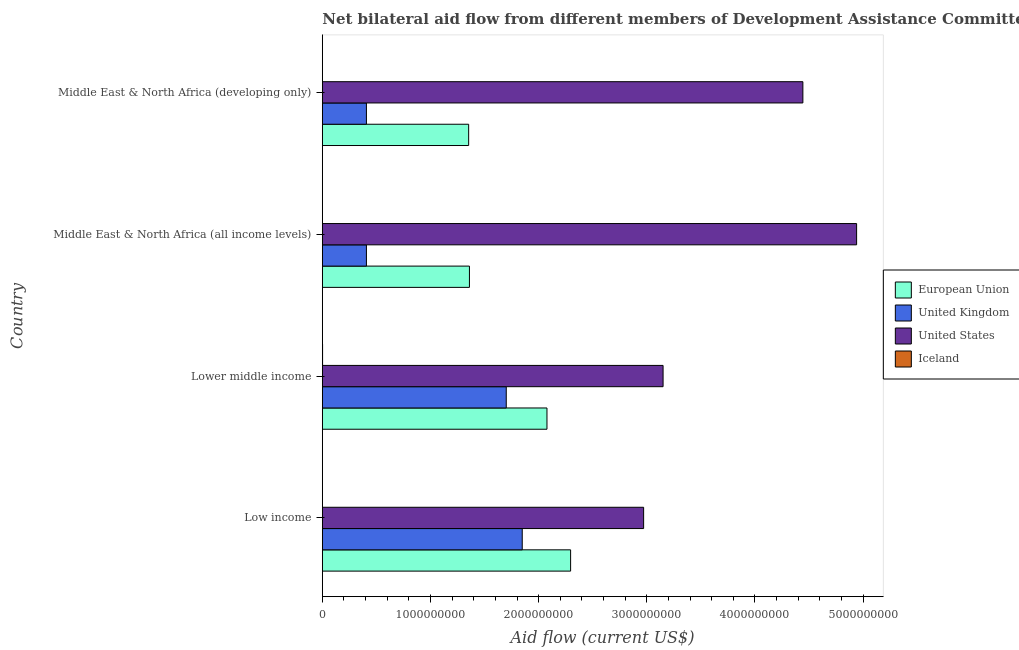How many groups of bars are there?
Provide a succinct answer. 4. Are the number of bars on each tick of the Y-axis equal?
Make the answer very short. Yes. How many bars are there on the 4th tick from the bottom?
Offer a terse response. 4. What is the label of the 1st group of bars from the top?
Provide a succinct answer. Middle East & North Africa (developing only). In how many cases, is the number of bars for a given country not equal to the number of legend labels?
Offer a very short reply. 0. What is the amount of aid given by us in Middle East & North Africa (all income levels)?
Your response must be concise. 4.94e+09. Across all countries, what is the maximum amount of aid given by iceland?
Offer a very short reply. 2.28e+06. Across all countries, what is the minimum amount of aid given by uk?
Make the answer very short. 4.08e+08. In which country was the amount of aid given by eu maximum?
Your answer should be very brief. Low income. In which country was the amount of aid given by uk minimum?
Provide a short and direct response. Middle East & North Africa (all income levels). What is the total amount of aid given by uk in the graph?
Provide a short and direct response. 4.36e+09. What is the difference between the amount of aid given by uk in Low income and that in Lower middle income?
Provide a succinct answer. 1.48e+08. What is the difference between the amount of aid given by eu in Middle East & North Africa (developing only) and the amount of aid given by us in Low income?
Your answer should be very brief. -1.62e+09. What is the average amount of aid given by uk per country?
Give a very brief answer. 1.09e+09. What is the difference between the amount of aid given by us and amount of aid given by uk in Middle East & North Africa (all income levels)?
Provide a succinct answer. 4.53e+09. What is the ratio of the amount of aid given by us in Middle East & North Africa (all income levels) to that in Middle East & North Africa (developing only)?
Keep it short and to the point. 1.11. Is the amount of aid given by us in Low income less than that in Middle East & North Africa (developing only)?
Ensure brevity in your answer.  Yes. What is the difference between the highest and the second highest amount of aid given by eu?
Offer a terse response. 2.19e+08. What is the difference between the highest and the lowest amount of aid given by eu?
Make the answer very short. 9.42e+08. In how many countries, is the amount of aid given by uk greater than the average amount of aid given by uk taken over all countries?
Offer a terse response. 2. What does the 1st bar from the top in Low income represents?
Your answer should be compact. Iceland. How many bars are there?
Make the answer very short. 16. How many countries are there in the graph?
Your response must be concise. 4. What is the difference between two consecutive major ticks on the X-axis?
Provide a short and direct response. 1.00e+09. Does the graph contain grids?
Provide a succinct answer. No. Where does the legend appear in the graph?
Your answer should be very brief. Center right. How many legend labels are there?
Your answer should be compact. 4. How are the legend labels stacked?
Make the answer very short. Vertical. What is the title of the graph?
Your answer should be very brief. Net bilateral aid flow from different members of Development Assistance Committee in the year 2004. Does "Debt policy" appear as one of the legend labels in the graph?
Ensure brevity in your answer.  No. What is the label or title of the X-axis?
Make the answer very short. Aid flow (current US$). What is the Aid flow (current US$) of European Union in Low income?
Your answer should be compact. 2.30e+09. What is the Aid flow (current US$) of United Kingdom in Low income?
Give a very brief answer. 1.85e+09. What is the Aid flow (current US$) in United States in Low income?
Your response must be concise. 2.97e+09. What is the Aid flow (current US$) of Iceland in Low income?
Your answer should be very brief. 1.54e+06. What is the Aid flow (current US$) in European Union in Lower middle income?
Your answer should be compact. 2.08e+09. What is the Aid flow (current US$) in United Kingdom in Lower middle income?
Provide a succinct answer. 1.70e+09. What is the Aid flow (current US$) of United States in Lower middle income?
Your answer should be very brief. 3.15e+09. What is the Aid flow (current US$) in Iceland in Lower middle income?
Make the answer very short. 2.28e+06. What is the Aid flow (current US$) in European Union in Middle East & North Africa (all income levels)?
Keep it short and to the point. 1.36e+09. What is the Aid flow (current US$) of United Kingdom in Middle East & North Africa (all income levels)?
Offer a terse response. 4.08e+08. What is the Aid flow (current US$) in United States in Middle East & North Africa (all income levels)?
Your response must be concise. 4.94e+09. What is the Aid flow (current US$) of Iceland in Middle East & North Africa (all income levels)?
Your answer should be compact. 1.24e+06. What is the Aid flow (current US$) in European Union in Middle East & North Africa (developing only)?
Make the answer very short. 1.35e+09. What is the Aid flow (current US$) in United Kingdom in Middle East & North Africa (developing only)?
Your answer should be very brief. 4.08e+08. What is the Aid flow (current US$) of United States in Middle East & North Africa (developing only)?
Keep it short and to the point. 4.44e+09. What is the Aid flow (current US$) in Iceland in Middle East & North Africa (developing only)?
Ensure brevity in your answer.  1.27e+06. Across all countries, what is the maximum Aid flow (current US$) of European Union?
Your answer should be compact. 2.30e+09. Across all countries, what is the maximum Aid flow (current US$) in United Kingdom?
Offer a terse response. 1.85e+09. Across all countries, what is the maximum Aid flow (current US$) of United States?
Your response must be concise. 4.94e+09. Across all countries, what is the maximum Aid flow (current US$) of Iceland?
Give a very brief answer. 2.28e+06. Across all countries, what is the minimum Aid flow (current US$) in European Union?
Your answer should be compact. 1.35e+09. Across all countries, what is the minimum Aid flow (current US$) in United Kingdom?
Keep it short and to the point. 4.08e+08. Across all countries, what is the minimum Aid flow (current US$) in United States?
Keep it short and to the point. 2.97e+09. Across all countries, what is the minimum Aid flow (current US$) of Iceland?
Your answer should be very brief. 1.24e+06. What is the total Aid flow (current US$) of European Union in the graph?
Offer a very short reply. 7.09e+09. What is the total Aid flow (current US$) of United Kingdom in the graph?
Your response must be concise. 4.36e+09. What is the total Aid flow (current US$) of United States in the graph?
Your answer should be compact. 1.55e+1. What is the total Aid flow (current US$) in Iceland in the graph?
Provide a short and direct response. 6.33e+06. What is the difference between the Aid flow (current US$) of European Union in Low income and that in Lower middle income?
Provide a short and direct response. 2.19e+08. What is the difference between the Aid flow (current US$) of United Kingdom in Low income and that in Lower middle income?
Offer a terse response. 1.48e+08. What is the difference between the Aid flow (current US$) in United States in Low income and that in Lower middle income?
Keep it short and to the point. -1.80e+08. What is the difference between the Aid flow (current US$) in Iceland in Low income and that in Lower middle income?
Your response must be concise. -7.40e+05. What is the difference between the Aid flow (current US$) of European Union in Low income and that in Middle East & North Africa (all income levels)?
Make the answer very short. 9.35e+08. What is the difference between the Aid flow (current US$) of United Kingdom in Low income and that in Middle East & North Africa (all income levels)?
Ensure brevity in your answer.  1.44e+09. What is the difference between the Aid flow (current US$) of United States in Low income and that in Middle East & North Africa (all income levels)?
Make the answer very short. -1.97e+09. What is the difference between the Aid flow (current US$) in Iceland in Low income and that in Middle East & North Africa (all income levels)?
Your answer should be very brief. 3.00e+05. What is the difference between the Aid flow (current US$) of European Union in Low income and that in Middle East & North Africa (developing only)?
Keep it short and to the point. 9.42e+08. What is the difference between the Aid flow (current US$) in United Kingdom in Low income and that in Middle East & North Africa (developing only)?
Offer a terse response. 1.44e+09. What is the difference between the Aid flow (current US$) of United States in Low income and that in Middle East & North Africa (developing only)?
Your answer should be compact. -1.47e+09. What is the difference between the Aid flow (current US$) in European Union in Lower middle income and that in Middle East & North Africa (all income levels)?
Provide a short and direct response. 7.17e+08. What is the difference between the Aid flow (current US$) of United Kingdom in Lower middle income and that in Middle East & North Africa (all income levels)?
Keep it short and to the point. 1.29e+09. What is the difference between the Aid flow (current US$) of United States in Lower middle income and that in Middle East & North Africa (all income levels)?
Offer a terse response. -1.79e+09. What is the difference between the Aid flow (current US$) of Iceland in Lower middle income and that in Middle East & North Africa (all income levels)?
Your response must be concise. 1.04e+06. What is the difference between the Aid flow (current US$) of European Union in Lower middle income and that in Middle East & North Africa (developing only)?
Your response must be concise. 7.24e+08. What is the difference between the Aid flow (current US$) of United Kingdom in Lower middle income and that in Middle East & North Africa (developing only)?
Keep it short and to the point. 1.29e+09. What is the difference between the Aid flow (current US$) of United States in Lower middle income and that in Middle East & North Africa (developing only)?
Make the answer very short. -1.29e+09. What is the difference between the Aid flow (current US$) in Iceland in Lower middle income and that in Middle East & North Africa (developing only)?
Ensure brevity in your answer.  1.01e+06. What is the difference between the Aid flow (current US$) in European Union in Middle East & North Africa (all income levels) and that in Middle East & North Africa (developing only)?
Make the answer very short. 7.17e+06. What is the difference between the Aid flow (current US$) in United Kingdom in Middle East & North Africa (all income levels) and that in Middle East & North Africa (developing only)?
Offer a very short reply. 0. What is the difference between the Aid flow (current US$) of United States in Middle East & North Africa (all income levels) and that in Middle East & North Africa (developing only)?
Ensure brevity in your answer.  4.97e+08. What is the difference between the Aid flow (current US$) in European Union in Low income and the Aid flow (current US$) in United Kingdom in Lower middle income?
Provide a succinct answer. 5.95e+08. What is the difference between the Aid flow (current US$) in European Union in Low income and the Aid flow (current US$) in United States in Lower middle income?
Offer a very short reply. -8.55e+08. What is the difference between the Aid flow (current US$) of European Union in Low income and the Aid flow (current US$) of Iceland in Lower middle income?
Provide a short and direct response. 2.29e+09. What is the difference between the Aid flow (current US$) of United Kingdom in Low income and the Aid flow (current US$) of United States in Lower middle income?
Make the answer very short. -1.30e+09. What is the difference between the Aid flow (current US$) in United Kingdom in Low income and the Aid flow (current US$) in Iceland in Lower middle income?
Make the answer very short. 1.85e+09. What is the difference between the Aid flow (current US$) in United States in Low income and the Aid flow (current US$) in Iceland in Lower middle income?
Your response must be concise. 2.97e+09. What is the difference between the Aid flow (current US$) in European Union in Low income and the Aid flow (current US$) in United Kingdom in Middle East & North Africa (all income levels)?
Ensure brevity in your answer.  1.89e+09. What is the difference between the Aid flow (current US$) in European Union in Low income and the Aid flow (current US$) in United States in Middle East & North Africa (all income levels)?
Your response must be concise. -2.64e+09. What is the difference between the Aid flow (current US$) in European Union in Low income and the Aid flow (current US$) in Iceland in Middle East & North Africa (all income levels)?
Offer a terse response. 2.29e+09. What is the difference between the Aid flow (current US$) of United Kingdom in Low income and the Aid flow (current US$) of United States in Middle East & North Africa (all income levels)?
Offer a very short reply. -3.09e+09. What is the difference between the Aid flow (current US$) in United Kingdom in Low income and the Aid flow (current US$) in Iceland in Middle East & North Africa (all income levels)?
Offer a terse response. 1.85e+09. What is the difference between the Aid flow (current US$) of United States in Low income and the Aid flow (current US$) of Iceland in Middle East & North Africa (all income levels)?
Offer a terse response. 2.97e+09. What is the difference between the Aid flow (current US$) of European Union in Low income and the Aid flow (current US$) of United Kingdom in Middle East & North Africa (developing only)?
Ensure brevity in your answer.  1.89e+09. What is the difference between the Aid flow (current US$) in European Union in Low income and the Aid flow (current US$) in United States in Middle East & North Africa (developing only)?
Ensure brevity in your answer.  -2.15e+09. What is the difference between the Aid flow (current US$) in European Union in Low income and the Aid flow (current US$) in Iceland in Middle East & North Africa (developing only)?
Your answer should be very brief. 2.29e+09. What is the difference between the Aid flow (current US$) in United Kingdom in Low income and the Aid flow (current US$) in United States in Middle East & North Africa (developing only)?
Make the answer very short. -2.59e+09. What is the difference between the Aid flow (current US$) of United Kingdom in Low income and the Aid flow (current US$) of Iceland in Middle East & North Africa (developing only)?
Ensure brevity in your answer.  1.85e+09. What is the difference between the Aid flow (current US$) in United States in Low income and the Aid flow (current US$) in Iceland in Middle East & North Africa (developing only)?
Give a very brief answer. 2.97e+09. What is the difference between the Aid flow (current US$) of European Union in Lower middle income and the Aid flow (current US$) of United Kingdom in Middle East & North Africa (all income levels)?
Make the answer very short. 1.67e+09. What is the difference between the Aid flow (current US$) in European Union in Lower middle income and the Aid flow (current US$) in United States in Middle East & North Africa (all income levels)?
Provide a succinct answer. -2.86e+09. What is the difference between the Aid flow (current US$) of European Union in Lower middle income and the Aid flow (current US$) of Iceland in Middle East & North Africa (all income levels)?
Ensure brevity in your answer.  2.08e+09. What is the difference between the Aid flow (current US$) in United Kingdom in Lower middle income and the Aid flow (current US$) in United States in Middle East & North Africa (all income levels)?
Your response must be concise. -3.24e+09. What is the difference between the Aid flow (current US$) of United Kingdom in Lower middle income and the Aid flow (current US$) of Iceland in Middle East & North Africa (all income levels)?
Your answer should be compact. 1.70e+09. What is the difference between the Aid flow (current US$) in United States in Lower middle income and the Aid flow (current US$) in Iceland in Middle East & North Africa (all income levels)?
Provide a succinct answer. 3.15e+09. What is the difference between the Aid flow (current US$) of European Union in Lower middle income and the Aid flow (current US$) of United Kingdom in Middle East & North Africa (developing only)?
Your response must be concise. 1.67e+09. What is the difference between the Aid flow (current US$) in European Union in Lower middle income and the Aid flow (current US$) in United States in Middle East & North Africa (developing only)?
Your response must be concise. -2.37e+09. What is the difference between the Aid flow (current US$) in European Union in Lower middle income and the Aid flow (current US$) in Iceland in Middle East & North Africa (developing only)?
Your answer should be compact. 2.08e+09. What is the difference between the Aid flow (current US$) of United Kingdom in Lower middle income and the Aid flow (current US$) of United States in Middle East & North Africa (developing only)?
Keep it short and to the point. -2.74e+09. What is the difference between the Aid flow (current US$) of United Kingdom in Lower middle income and the Aid flow (current US$) of Iceland in Middle East & North Africa (developing only)?
Your response must be concise. 1.70e+09. What is the difference between the Aid flow (current US$) in United States in Lower middle income and the Aid flow (current US$) in Iceland in Middle East & North Africa (developing only)?
Offer a very short reply. 3.15e+09. What is the difference between the Aid flow (current US$) in European Union in Middle East & North Africa (all income levels) and the Aid flow (current US$) in United Kingdom in Middle East & North Africa (developing only)?
Offer a very short reply. 9.52e+08. What is the difference between the Aid flow (current US$) in European Union in Middle East & North Africa (all income levels) and the Aid flow (current US$) in United States in Middle East & North Africa (developing only)?
Make the answer very short. -3.08e+09. What is the difference between the Aid flow (current US$) of European Union in Middle East & North Africa (all income levels) and the Aid flow (current US$) of Iceland in Middle East & North Africa (developing only)?
Offer a terse response. 1.36e+09. What is the difference between the Aid flow (current US$) of United Kingdom in Middle East & North Africa (all income levels) and the Aid flow (current US$) of United States in Middle East & North Africa (developing only)?
Ensure brevity in your answer.  -4.04e+09. What is the difference between the Aid flow (current US$) in United Kingdom in Middle East & North Africa (all income levels) and the Aid flow (current US$) in Iceland in Middle East & North Africa (developing only)?
Ensure brevity in your answer.  4.06e+08. What is the difference between the Aid flow (current US$) of United States in Middle East & North Africa (all income levels) and the Aid flow (current US$) of Iceland in Middle East & North Africa (developing only)?
Offer a very short reply. 4.94e+09. What is the average Aid flow (current US$) of European Union per country?
Offer a very short reply. 1.77e+09. What is the average Aid flow (current US$) in United Kingdom per country?
Make the answer very short. 1.09e+09. What is the average Aid flow (current US$) of United States per country?
Provide a short and direct response. 3.88e+09. What is the average Aid flow (current US$) of Iceland per country?
Provide a succinct answer. 1.58e+06. What is the difference between the Aid flow (current US$) in European Union and Aid flow (current US$) in United Kingdom in Low income?
Provide a succinct answer. 4.47e+08. What is the difference between the Aid flow (current US$) of European Union and Aid flow (current US$) of United States in Low income?
Give a very brief answer. -6.75e+08. What is the difference between the Aid flow (current US$) in European Union and Aid flow (current US$) in Iceland in Low income?
Give a very brief answer. 2.29e+09. What is the difference between the Aid flow (current US$) of United Kingdom and Aid flow (current US$) of United States in Low income?
Offer a very short reply. -1.12e+09. What is the difference between the Aid flow (current US$) of United Kingdom and Aid flow (current US$) of Iceland in Low income?
Give a very brief answer. 1.85e+09. What is the difference between the Aid flow (current US$) in United States and Aid flow (current US$) in Iceland in Low income?
Your answer should be compact. 2.97e+09. What is the difference between the Aid flow (current US$) of European Union and Aid flow (current US$) of United Kingdom in Lower middle income?
Your answer should be very brief. 3.76e+08. What is the difference between the Aid flow (current US$) in European Union and Aid flow (current US$) in United States in Lower middle income?
Keep it short and to the point. -1.07e+09. What is the difference between the Aid flow (current US$) of European Union and Aid flow (current US$) of Iceland in Lower middle income?
Your answer should be compact. 2.07e+09. What is the difference between the Aid flow (current US$) in United Kingdom and Aid flow (current US$) in United States in Lower middle income?
Ensure brevity in your answer.  -1.45e+09. What is the difference between the Aid flow (current US$) of United Kingdom and Aid flow (current US$) of Iceland in Lower middle income?
Your answer should be compact. 1.70e+09. What is the difference between the Aid flow (current US$) of United States and Aid flow (current US$) of Iceland in Lower middle income?
Provide a succinct answer. 3.15e+09. What is the difference between the Aid flow (current US$) in European Union and Aid flow (current US$) in United Kingdom in Middle East & North Africa (all income levels)?
Your answer should be compact. 9.52e+08. What is the difference between the Aid flow (current US$) of European Union and Aid flow (current US$) of United States in Middle East & North Africa (all income levels)?
Offer a terse response. -3.58e+09. What is the difference between the Aid flow (current US$) of European Union and Aid flow (current US$) of Iceland in Middle East & North Africa (all income levels)?
Give a very brief answer. 1.36e+09. What is the difference between the Aid flow (current US$) in United Kingdom and Aid flow (current US$) in United States in Middle East & North Africa (all income levels)?
Provide a succinct answer. -4.53e+09. What is the difference between the Aid flow (current US$) of United Kingdom and Aid flow (current US$) of Iceland in Middle East & North Africa (all income levels)?
Offer a very short reply. 4.06e+08. What is the difference between the Aid flow (current US$) in United States and Aid flow (current US$) in Iceland in Middle East & North Africa (all income levels)?
Provide a short and direct response. 4.94e+09. What is the difference between the Aid flow (current US$) of European Union and Aid flow (current US$) of United Kingdom in Middle East & North Africa (developing only)?
Offer a terse response. 9.45e+08. What is the difference between the Aid flow (current US$) in European Union and Aid flow (current US$) in United States in Middle East & North Africa (developing only)?
Offer a very short reply. -3.09e+09. What is the difference between the Aid flow (current US$) in European Union and Aid flow (current US$) in Iceland in Middle East & North Africa (developing only)?
Give a very brief answer. 1.35e+09. What is the difference between the Aid flow (current US$) in United Kingdom and Aid flow (current US$) in United States in Middle East & North Africa (developing only)?
Give a very brief answer. -4.04e+09. What is the difference between the Aid flow (current US$) of United Kingdom and Aid flow (current US$) of Iceland in Middle East & North Africa (developing only)?
Keep it short and to the point. 4.06e+08. What is the difference between the Aid flow (current US$) in United States and Aid flow (current US$) in Iceland in Middle East & North Africa (developing only)?
Provide a short and direct response. 4.44e+09. What is the ratio of the Aid flow (current US$) of European Union in Low income to that in Lower middle income?
Offer a very short reply. 1.11. What is the ratio of the Aid flow (current US$) of United Kingdom in Low income to that in Lower middle income?
Give a very brief answer. 1.09. What is the ratio of the Aid flow (current US$) in United States in Low income to that in Lower middle income?
Keep it short and to the point. 0.94. What is the ratio of the Aid flow (current US$) in Iceland in Low income to that in Lower middle income?
Your answer should be very brief. 0.68. What is the ratio of the Aid flow (current US$) of European Union in Low income to that in Middle East & North Africa (all income levels)?
Ensure brevity in your answer.  1.69. What is the ratio of the Aid flow (current US$) in United Kingdom in Low income to that in Middle East & North Africa (all income levels)?
Your answer should be compact. 4.53. What is the ratio of the Aid flow (current US$) of United States in Low income to that in Middle East & North Africa (all income levels)?
Keep it short and to the point. 0.6. What is the ratio of the Aid flow (current US$) of Iceland in Low income to that in Middle East & North Africa (all income levels)?
Your answer should be compact. 1.24. What is the ratio of the Aid flow (current US$) in European Union in Low income to that in Middle East & North Africa (developing only)?
Offer a very short reply. 1.7. What is the ratio of the Aid flow (current US$) in United Kingdom in Low income to that in Middle East & North Africa (developing only)?
Your response must be concise. 4.53. What is the ratio of the Aid flow (current US$) of United States in Low income to that in Middle East & North Africa (developing only)?
Offer a terse response. 0.67. What is the ratio of the Aid flow (current US$) of Iceland in Low income to that in Middle East & North Africa (developing only)?
Offer a terse response. 1.21. What is the ratio of the Aid flow (current US$) of European Union in Lower middle income to that in Middle East & North Africa (all income levels)?
Give a very brief answer. 1.53. What is the ratio of the Aid flow (current US$) of United Kingdom in Lower middle income to that in Middle East & North Africa (all income levels)?
Your response must be concise. 4.17. What is the ratio of the Aid flow (current US$) of United States in Lower middle income to that in Middle East & North Africa (all income levels)?
Provide a short and direct response. 0.64. What is the ratio of the Aid flow (current US$) in Iceland in Lower middle income to that in Middle East & North Africa (all income levels)?
Your answer should be compact. 1.84. What is the ratio of the Aid flow (current US$) in European Union in Lower middle income to that in Middle East & North Africa (developing only)?
Keep it short and to the point. 1.54. What is the ratio of the Aid flow (current US$) in United Kingdom in Lower middle income to that in Middle East & North Africa (developing only)?
Ensure brevity in your answer.  4.17. What is the ratio of the Aid flow (current US$) of United States in Lower middle income to that in Middle East & North Africa (developing only)?
Provide a succinct answer. 0.71. What is the ratio of the Aid flow (current US$) in Iceland in Lower middle income to that in Middle East & North Africa (developing only)?
Offer a terse response. 1.8. What is the ratio of the Aid flow (current US$) of European Union in Middle East & North Africa (all income levels) to that in Middle East & North Africa (developing only)?
Provide a succinct answer. 1.01. What is the ratio of the Aid flow (current US$) of United States in Middle East & North Africa (all income levels) to that in Middle East & North Africa (developing only)?
Make the answer very short. 1.11. What is the ratio of the Aid flow (current US$) of Iceland in Middle East & North Africa (all income levels) to that in Middle East & North Africa (developing only)?
Ensure brevity in your answer.  0.98. What is the difference between the highest and the second highest Aid flow (current US$) in European Union?
Your answer should be compact. 2.19e+08. What is the difference between the highest and the second highest Aid flow (current US$) of United Kingdom?
Your response must be concise. 1.48e+08. What is the difference between the highest and the second highest Aid flow (current US$) of United States?
Provide a short and direct response. 4.97e+08. What is the difference between the highest and the second highest Aid flow (current US$) in Iceland?
Provide a short and direct response. 7.40e+05. What is the difference between the highest and the lowest Aid flow (current US$) of European Union?
Keep it short and to the point. 9.42e+08. What is the difference between the highest and the lowest Aid flow (current US$) of United Kingdom?
Give a very brief answer. 1.44e+09. What is the difference between the highest and the lowest Aid flow (current US$) of United States?
Your answer should be very brief. 1.97e+09. What is the difference between the highest and the lowest Aid flow (current US$) in Iceland?
Your answer should be compact. 1.04e+06. 